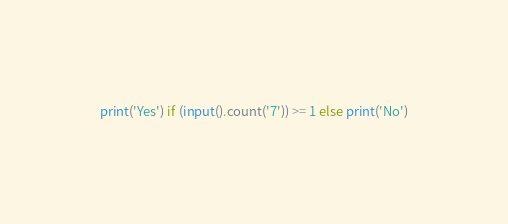<code> <loc_0><loc_0><loc_500><loc_500><_Python_>print('Yes') if (input().count('7')) >= 1 else print('No')
</code> 